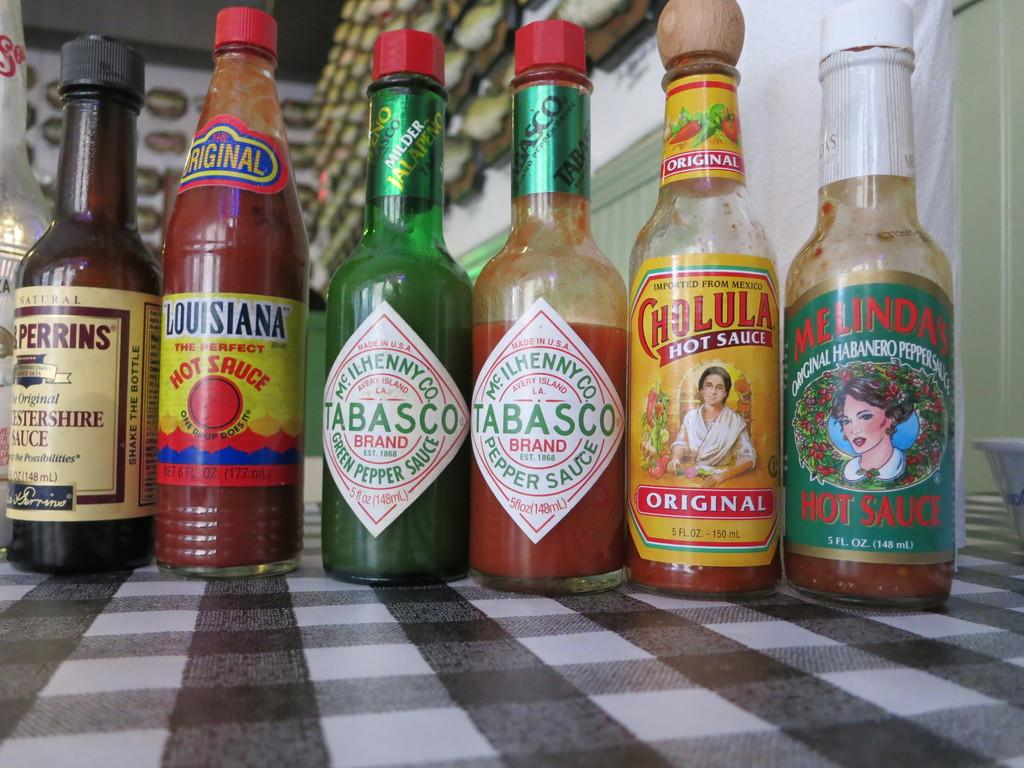<image>
Give a short and clear explanation of the subsequent image. Hot sauce bottles with a diamond label with Green lettering of Tabasco. 